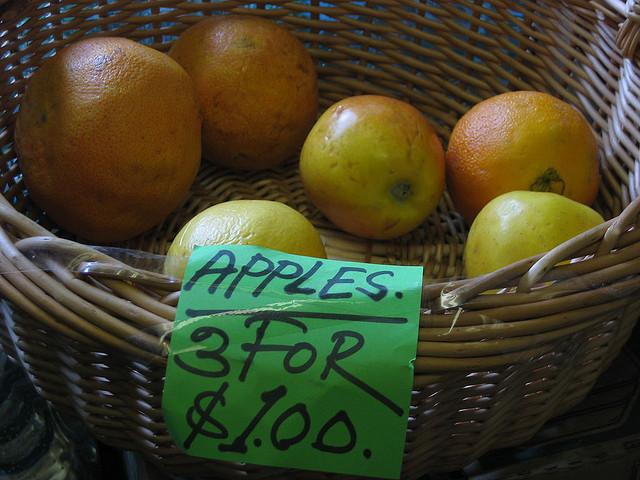What does the sign say?
Quick response, please. Apples 3 for $1.00. What besides apples are in the basket?
Write a very short answer. Oranges. How is the sign affixed to the basket?
Write a very short answer. Tape. 